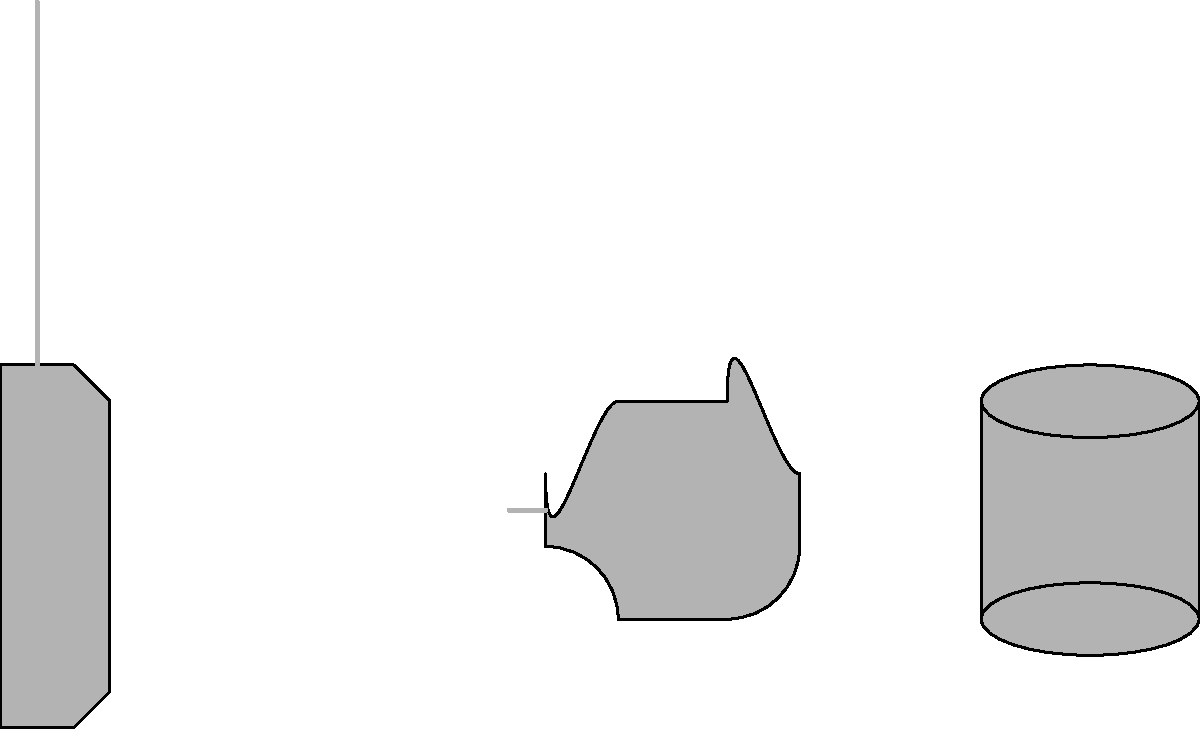As a music teacher organizing talent showcases, you need to quickly identify instruments. Which of the following instruments is represented by the silhouette in the middle of the image? To identify the instrument in the middle of the image, let's analyze the silhouettes step-by-step:

1. Left silhouette:
   - Has a distinct body and long neck
   - Shape resembles a guitar

2. Middle silhouette:
   - Has a curved, compact shape
   - Features a small protrusion on the left side (likely the mouthpiece)
   - Overall form is consistent with a brass instrument

3. Right silhouette:
   - Cylindrical shape with flat top and bottom
   - Proportions suggest a percussion instrument

The middle silhouette's characteristics, including its curved shape and visible mouthpiece, are typical of a trumpet. The compact design and the slight flare towards the right side (representing the bell of the instrument) further confirm this identification.
Answer: Trumpet 